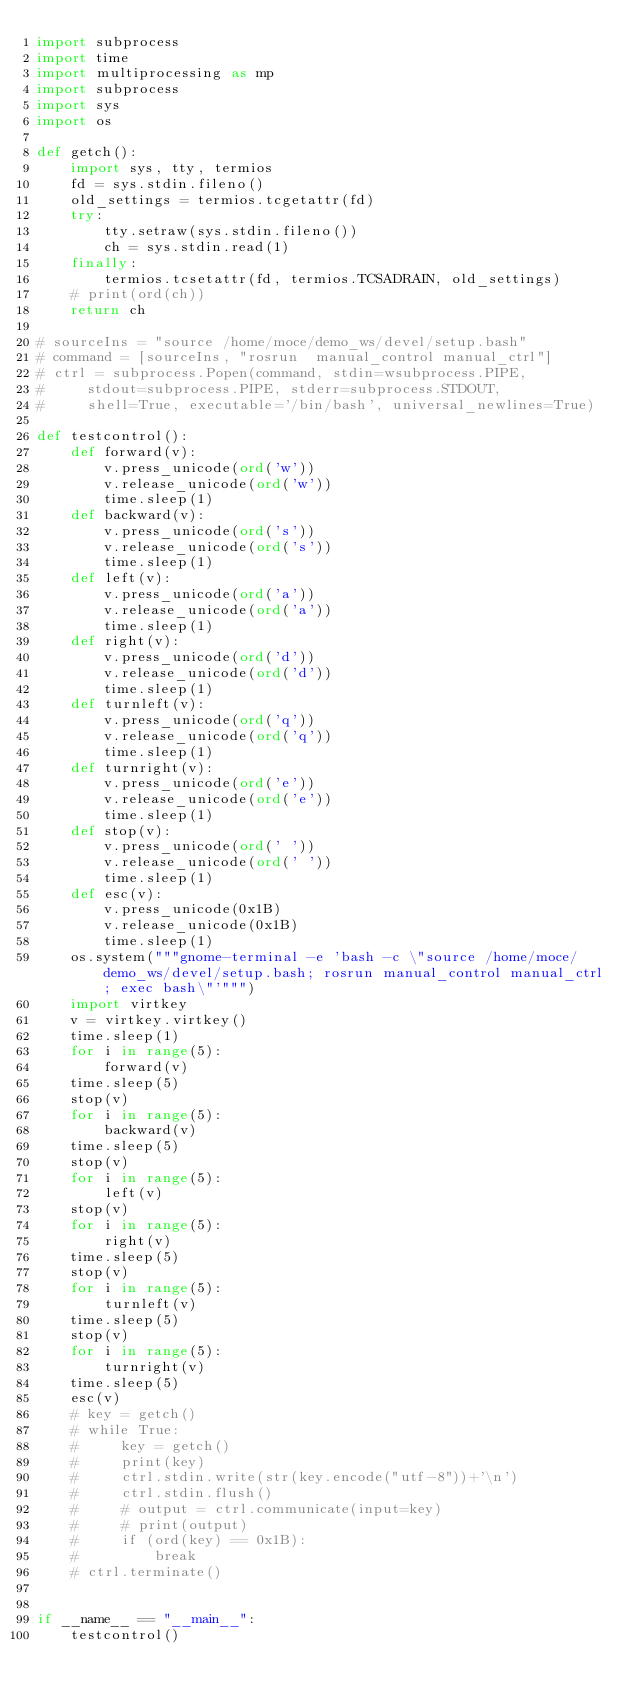Convert code to text. <code><loc_0><loc_0><loc_500><loc_500><_Python_>import subprocess
import time
import multiprocessing as mp
import subprocess
import sys
import os

def getch():
    import sys, tty, termios
    fd = sys.stdin.fileno()
    old_settings = termios.tcgetattr(fd)
    try:
        tty.setraw(sys.stdin.fileno())
        ch = sys.stdin.read(1)
    finally:
        termios.tcsetattr(fd, termios.TCSADRAIN, old_settings)
    # print(ord(ch))
    return ch

# sourceIns = "source /home/moce/demo_ws/devel/setup.bash"
# command = [sourceIns, "rosrun  manual_control manual_ctrl"]
# ctrl = subprocess.Popen(command, stdin=wsubprocess.PIPE, 
#     stdout=subprocess.PIPE, stderr=subprocess.STDOUT, 
#     shell=True, executable='/bin/bash', universal_newlines=True)

def testcontrol():
    def forward(v):
        v.press_unicode(ord('w'))
        v.release_unicode(ord('w'))
        time.sleep(1)
    def backward(v):
        v.press_unicode(ord('s'))
        v.release_unicode(ord('s'))
        time.sleep(1)
    def left(v):
        v.press_unicode(ord('a'))
        v.release_unicode(ord('a'))
        time.sleep(1)
    def right(v):
        v.press_unicode(ord('d'))
        v.release_unicode(ord('d'))
        time.sleep(1)
    def turnleft(v):
        v.press_unicode(ord('q'))
        v.release_unicode(ord('q'))
        time.sleep(1)
    def turnright(v):
        v.press_unicode(ord('e'))
        v.release_unicode(ord('e'))
        time.sleep(1)
    def stop(v):
        v.press_unicode(ord(' '))
        v.release_unicode(ord(' '))
        time.sleep(1)
    def esc(v):
        v.press_unicode(0x1B)
        v.release_unicode(0x1B)
        time.sleep(1)
    os.system("""gnome-terminal -e 'bash -c \"source /home/moce/demo_ws/devel/setup.bash; rosrun manual_control manual_ctrl; exec bash\"'""")
    import virtkey
    v = virtkey.virtkey()
    time.sleep(1)
    for i in range(5):
        forward(v)
    time.sleep(5)
    stop(v)
    for i in range(5):
        backward(v)
    time.sleep(5)
    stop(v)
    for i in range(5):
        left(v)
    stop(v)
    for i in range(5):
        right(v)
    time.sleep(5)
    stop(v)
    for i in range(5):
        turnleft(v)
    time.sleep(5)
    stop(v)
    for i in range(5):
        turnright(v)
    time.sleep(5)
    esc(v)
    # key = getch()
    # while True:
    #     key = getch()
    #     print(key)
    #     ctrl.stdin.write(str(key.encode("utf-8"))+'\n')
    #     ctrl.stdin.flush()
    #     # output = ctrl.communicate(input=key)
    #     # print(output)
    #     if (ord(key) == 0x1B):
    #         break
    # ctrl.terminate()


if __name__ == "__main__":
    testcontrol()</code> 